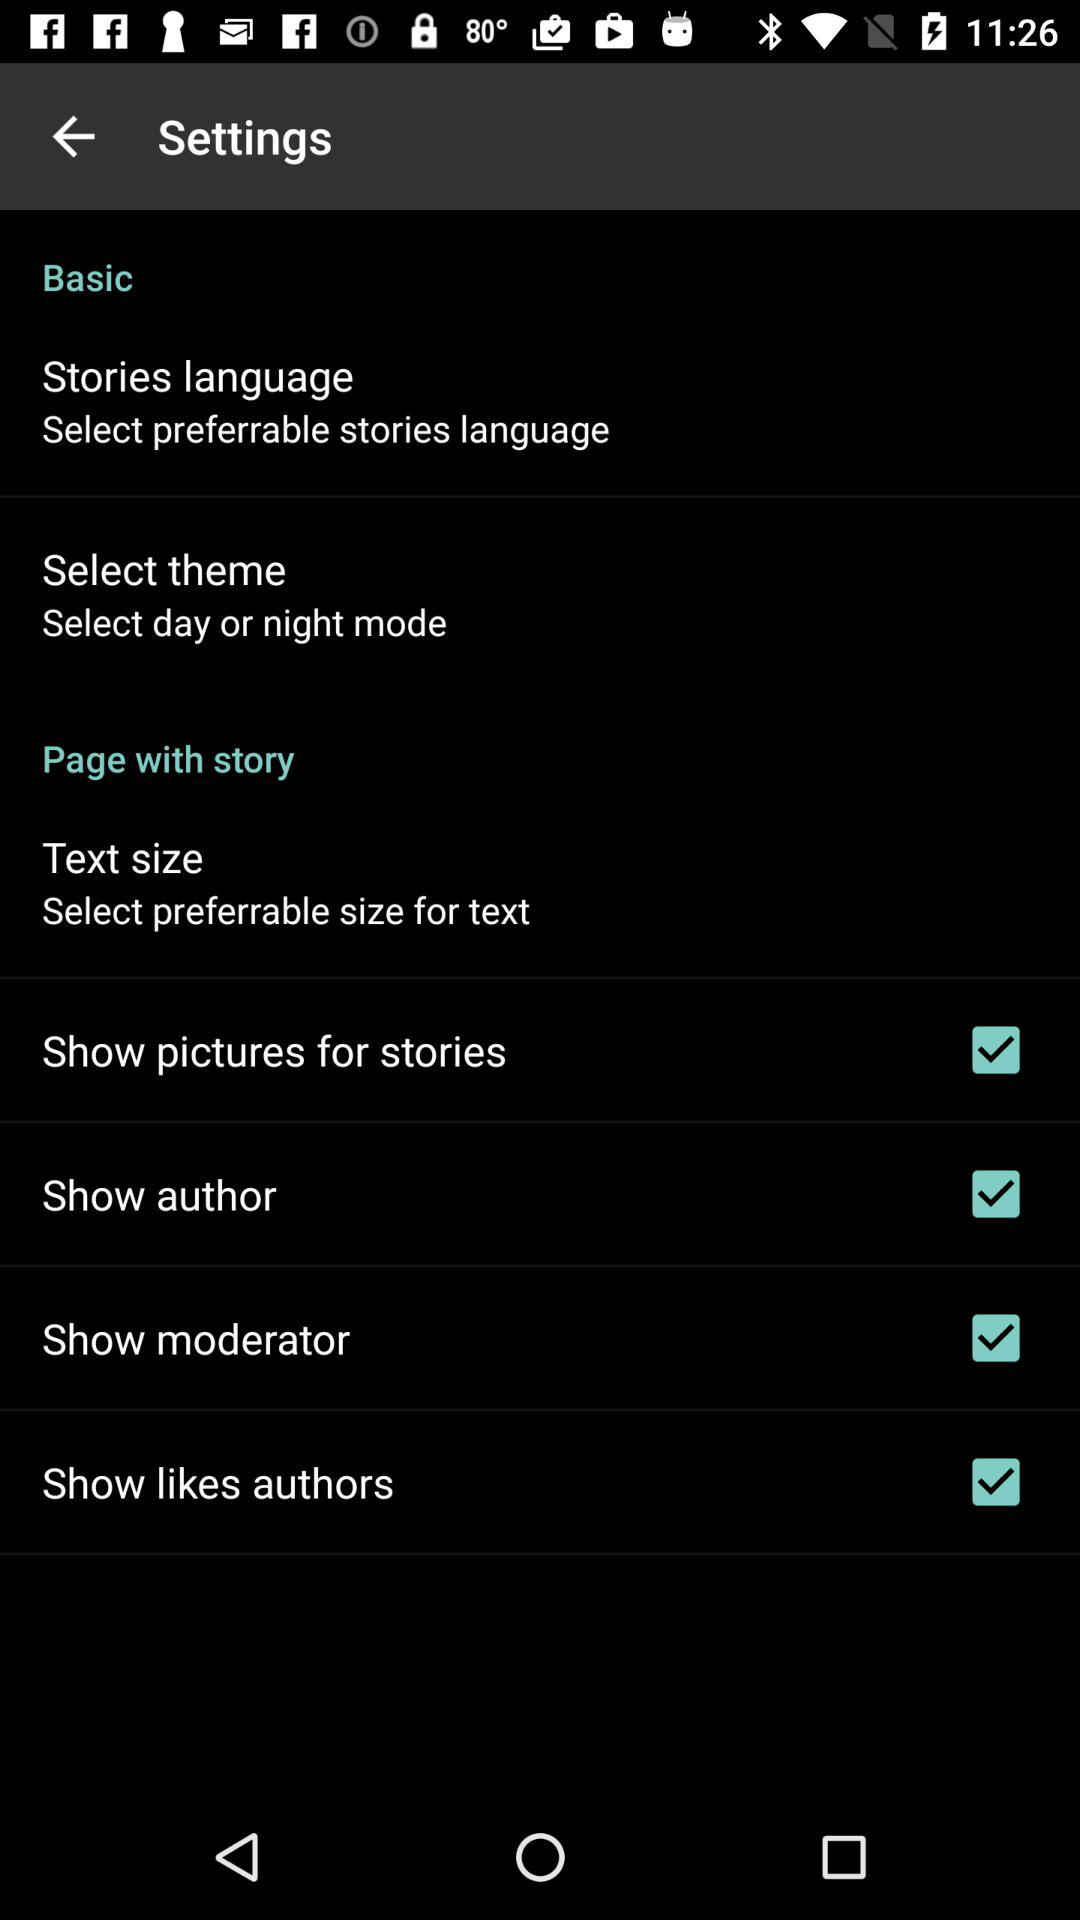What is the status of the "Show author"? The status is "on". 